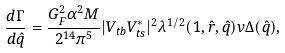<formula> <loc_0><loc_0><loc_500><loc_500>\frac { d \Gamma } { d \hat { q } } = \frac { G _ { F } ^ { 2 } \alpha ^ { 2 } M } { 2 ^ { 1 4 } \pi ^ { 5 } } | V _ { t b } V _ { t s } ^ { * } | ^ { 2 } \lambda ^ { 1 / 2 } ( 1 , \hat { r } , \hat { q } ) v \Delta ( \hat { q } ) ,</formula> 